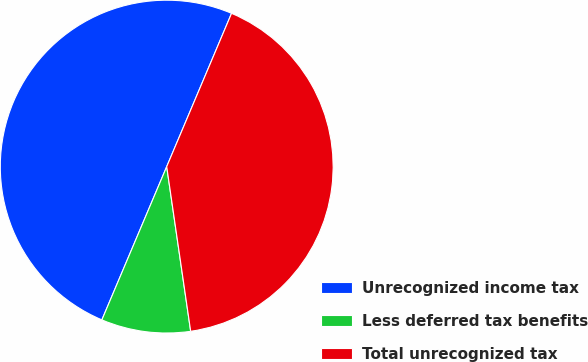Convert chart. <chart><loc_0><loc_0><loc_500><loc_500><pie_chart><fcel>Unrecognized income tax<fcel>Less deferred tax benefits<fcel>Total unrecognized tax<nl><fcel>50.0%<fcel>8.67%<fcel>41.33%<nl></chart> 